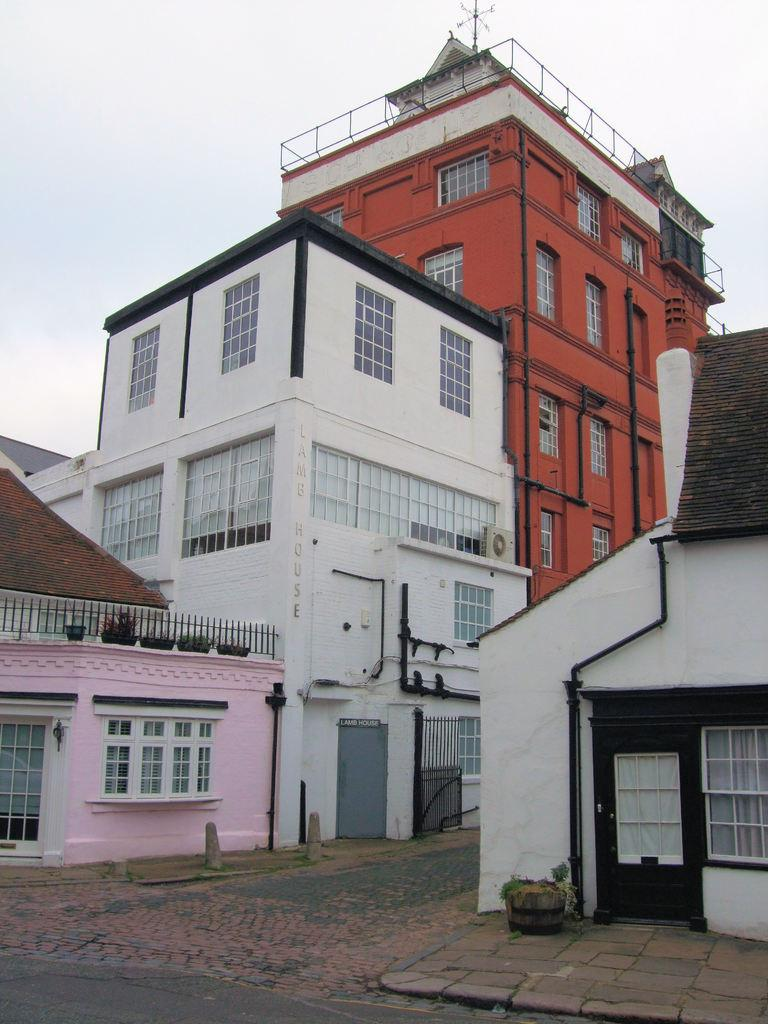What type of structures are present in the image? There are buildings in the image. What feature do the buildings have? The buildings have windows. What other objects can be seen in the image? There are plants and pipes in the image. How would you describe the sky in the image? The sky is cloudy. Can you tell me who created the clover in the image? There is no clover present in the image, so it is not possible to determine who created it. 